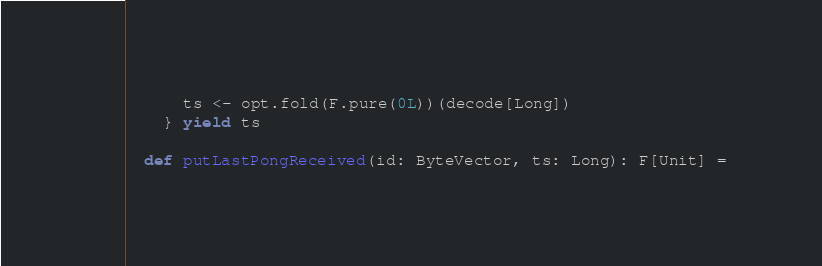Convert code to text. <code><loc_0><loc_0><loc_500><loc_500><_Scala_>      ts <- opt.fold(F.pure(0L))(decode[Long])
    } yield ts

  def putLastPongReceived(id: ByteVector, ts: Long): F[Unit] =</code> 